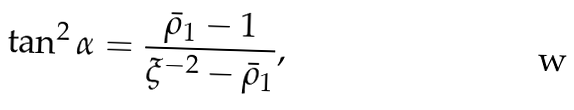Convert formula to latex. <formula><loc_0><loc_0><loc_500><loc_500>\tan ^ { 2 } \alpha = \frac { \bar { \rho } _ { 1 } - 1 } { \xi ^ { - 2 } - \bar { \rho } _ { 1 } } ,</formula> 